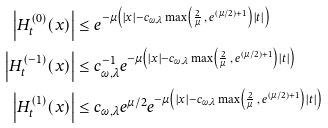<formula> <loc_0><loc_0><loc_500><loc_500>\left | H _ { t } ^ { ( 0 ) } ( x ) \right | & \leq e ^ { - \mu \left ( | x | - c _ { \omega , \lambda } \max \left ( \frac { 2 } { \mu } \, , \, e ^ { ( \mu / 2 ) + 1 } \right ) | t | \right ) } \\ \left | H _ { t } ^ { ( - 1 ) } ( x ) \right | & \leq c ^ { - 1 } _ { \omega , \lambda } e ^ { - \mu \left ( | x | - c _ { \omega , \lambda } \max \left ( \frac { 2 } { \mu } \, , \, e ^ { ( \mu / 2 ) + 1 } \right ) | t | \right ) } \\ \left | H _ { t } ^ { ( 1 ) } ( x ) \right | & \leq c _ { \omega , \lambda } e ^ { \mu / 2 } e ^ { - \mu \left ( | x | - c _ { \omega , \lambda } \max \left ( \frac { 2 } { \mu } \, , \, e ^ { ( \mu / 2 ) + 1 } \right ) | t | \right ) }</formula> 